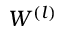<formula> <loc_0><loc_0><loc_500><loc_500>W ^ { ( l ) }</formula> 